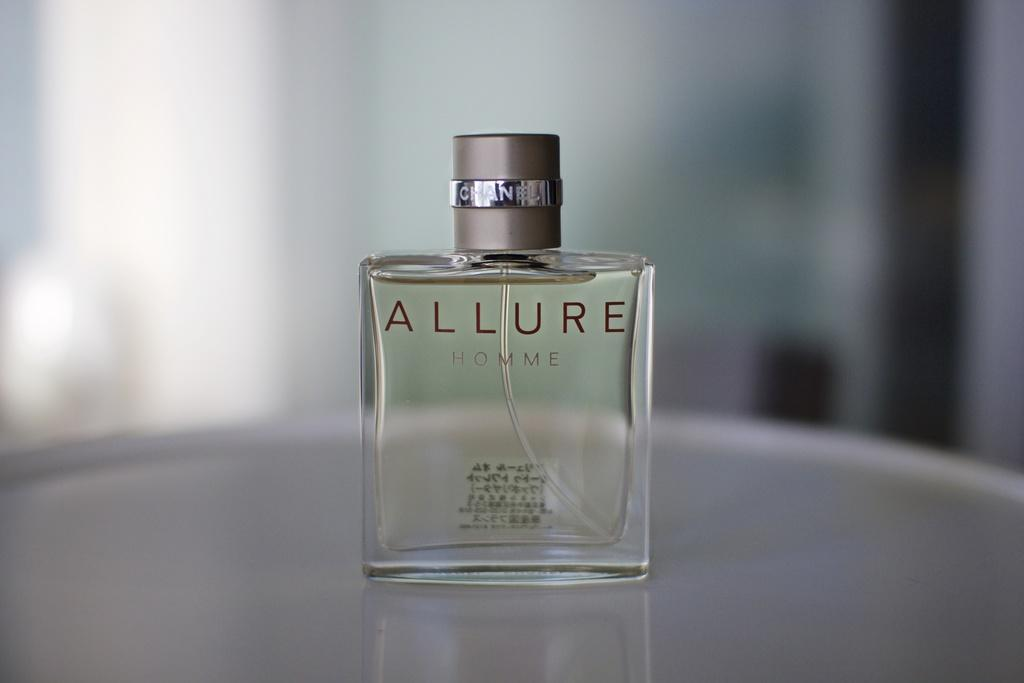<image>
Offer a succinct explanation of the picture presented. A bottle of perfume that is called allure homme. 